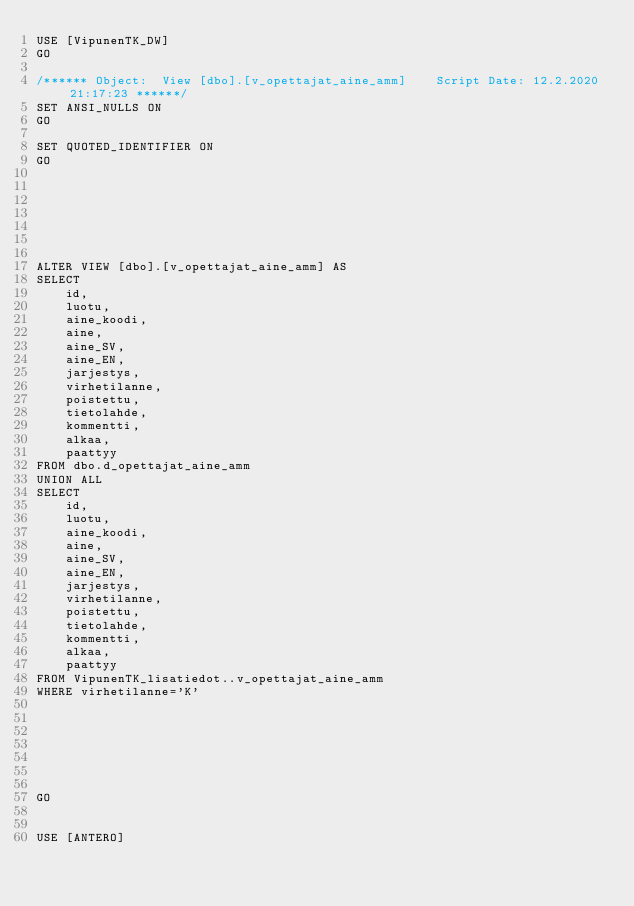<code> <loc_0><loc_0><loc_500><loc_500><_SQL_>USE [VipunenTK_DW]
GO

/****** Object:  View [dbo].[v_opettajat_aine_amm]    Script Date: 12.2.2020 21:17:23 ******/
SET ANSI_NULLS ON
GO

SET QUOTED_IDENTIFIER ON
GO







ALTER VIEW [dbo].[v_opettajat_aine_amm] AS
SELECT
	id,
	luotu,
	aine_koodi,
	aine,
	aine_SV,
	aine_EN,
	jarjestys,
	virhetilanne,
	poistettu,
	tietolahde,
	kommentti,
	alkaa,
	paattyy
FROM dbo.d_opettajat_aine_amm
UNION ALL
SELECT
	id,
	luotu,
	aine_koodi,
	aine,
	aine_SV,
	aine_EN,
	jarjestys,
	virhetilanne,
	poistettu,
	tietolahde,
	kommentti,
	alkaa,
	paattyy
FROM VipunenTK_lisatiedot..v_opettajat_aine_amm
WHERE virhetilanne='K'







GO


USE [ANTERO]</code> 